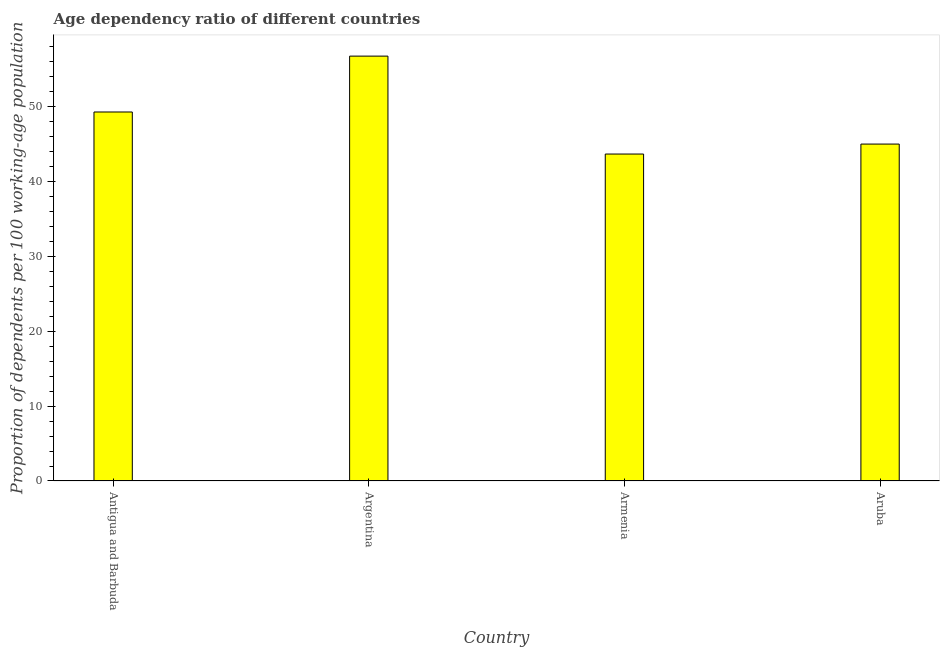Does the graph contain grids?
Provide a succinct answer. No. What is the title of the graph?
Offer a very short reply. Age dependency ratio of different countries. What is the label or title of the X-axis?
Provide a short and direct response. Country. What is the label or title of the Y-axis?
Keep it short and to the point. Proportion of dependents per 100 working-age population. What is the age dependency ratio in Antigua and Barbuda?
Ensure brevity in your answer.  49.28. Across all countries, what is the maximum age dependency ratio?
Offer a very short reply. 56.74. Across all countries, what is the minimum age dependency ratio?
Your answer should be very brief. 43.66. In which country was the age dependency ratio maximum?
Keep it short and to the point. Argentina. In which country was the age dependency ratio minimum?
Offer a terse response. Armenia. What is the sum of the age dependency ratio?
Keep it short and to the point. 194.67. What is the difference between the age dependency ratio in Argentina and Armenia?
Make the answer very short. 13.08. What is the average age dependency ratio per country?
Give a very brief answer. 48.67. What is the median age dependency ratio?
Provide a succinct answer. 47.13. In how many countries, is the age dependency ratio greater than 40 ?
Your response must be concise. 4. What is the ratio of the age dependency ratio in Armenia to that in Aruba?
Make the answer very short. 0.97. Is the age dependency ratio in Antigua and Barbuda less than that in Argentina?
Offer a terse response. Yes. What is the difference between the highest and the second highest age dependency ratio?
Offer a terse response. 7.46. Is the sum of the age dependency ratio in Argentina and Armenia greater than the maximum age dependency ratio across all countries?
Provide a succinct answer. Yes. What is the difference between the highest and the lowest age dependency ratio?
Provide a short and direct response. 13.08. How many bars are there?
Your answer should be compact. 4. What is the difference between two consecutive major ticks on the Y-axis?
Your response must be concise. 10. What is the Proportion of dependents per 100 working-age population in Antigua and Barbuda?
Ensure brevity in your answer.  49.28. What is the Proportion of dependents per 100 working-age population of Argentina?
Your answer should be compact. 56.74. What is the Proportion of dependents per 100 working-age population of Armenia?
Offer a terse response. 43.66. What is the Proportion of dependents per 100 working-age population of Aruba?
Ensure brevity in your answer.  44.99. What is the difference between the Proportion of dependents per 100 working-age population in Antigua and Barbuda and Argentina?
Provide a succinct answer. -7.46. What is the difference between the Proportion of dependents per 100 working-age population in Antigua and Barbuda and Armenia?
Offer a very short reply. 5.61. What is the difference between the Proportion of dependents per 100 working-age population in Antigua and Barbuda and Aruba?
Make the answer very short. 4.28. What is the difference between the Proportion of dependents per 100 working-age population in Argentina and Armenia?
Your answer should be compact. 13.08. What is the difference between the Proportion of dependents per 100 working-age population in Argentina and Aruba?
Your answer should be compact. 11.74. What is the difference between the Proportion of dependents per 100 working-age population in Armenia and Aruba?
Your answer should be compact. -1.33. What is the ratio of the Proportion of dependents per 100 working-age population in Antigua and Barbuda to that in Argentina?
Keep it short and to the point. 0.87. What is the ratio of the Proportion of dependents per 100 working-age population in Antigua and Barbuda to that in Armenia?
Keep it short and to the point. 1.13. What is the ratio of the Proportion of dependents per 100 working-age population in Antigua and Barbuda to that in Aruba?
Provide a succinct answer. 1.09. What is the ratio of the Proportion of dependents per 100 working-age population in Argentina to that in Armenia?
Offer a very short reply. 1.3. What is the ratio of the Proportion of dependents per 100 working-age population in Argentina to that in Aruba?
Your response must be concise. 1.26. What is the ratio of the Proportion of dependents per 100 working-age population in Armenia to that in Aruba?
Make the answer very short. 0.97. 